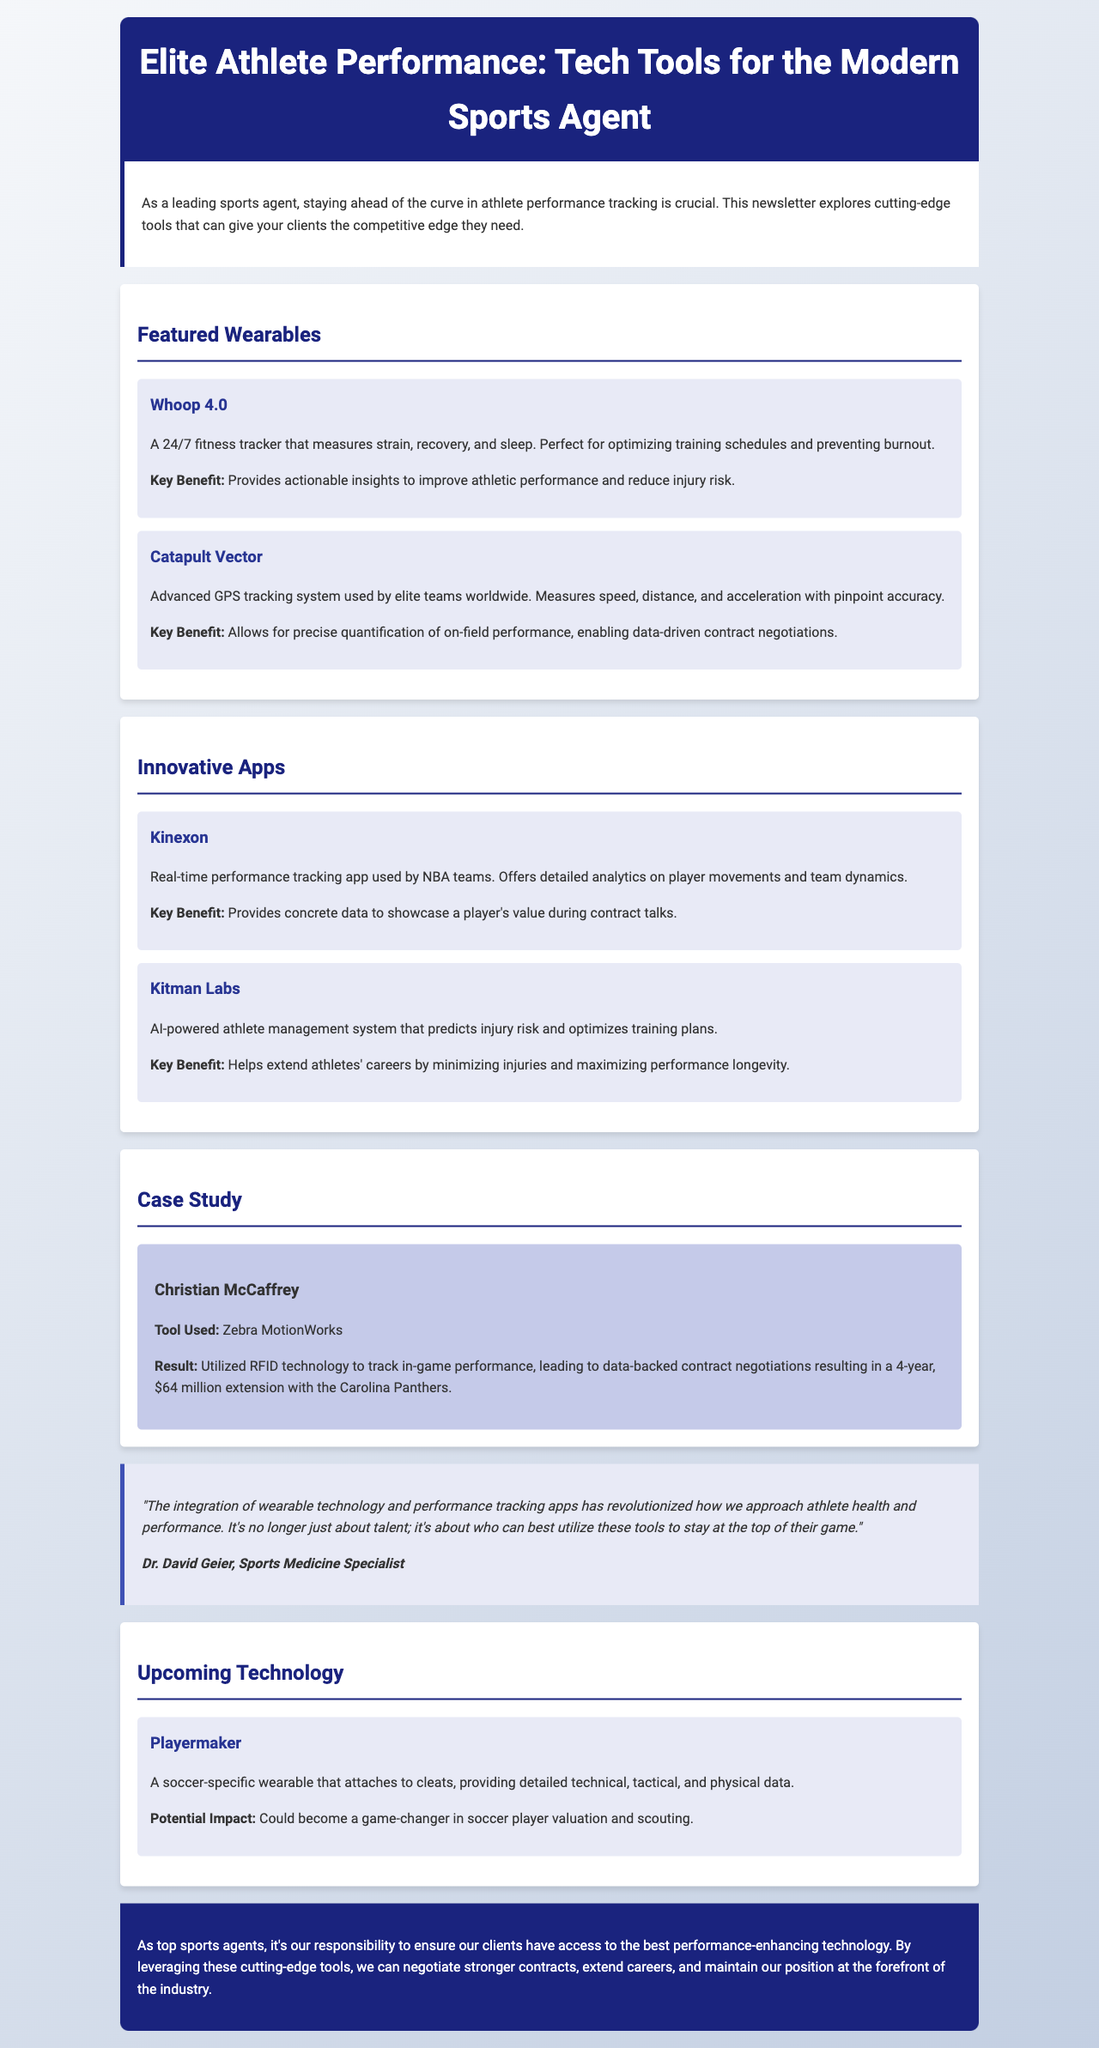what is the title of the newsletter? The title of the newsletter is the main heading presented at the top of the document.
Answer: Elite Athlete Performance: Tech Tools for the Modern Sports Agent which wearable is described as a 24/7 fitness tracker? This information can be found in the section detailing the featured wearables.
Answer: Whoop 4.0 who is the athlete mentioned in the case study? This is the name of the athlete highlighted in the specific case study section of the document.
Answer: Christian McCaffrey what is the key benefit of Kitman Labs? This benefit is provided in the description of the innovative apps and it highlights the specific advantage offered by the app.
Answer: Helps extend athletes' careers by minimizing injuries and maximizing performance longevity what technology does Playermaker pertain to? This describes the type of technology being introduced and its specific application.
Answer: A soccer-specific wearable how much was Christian McCaffrey's contract extension worth? This figure is stated in the results of the case study indicating the financial outcome of the negotiations.
Answer: $64 million which expert provided a quote in the document? This is the name of the specialist who offered insights in the form of a quote.
Answer: Dr. David Geier what is the main responsibility of top sports agents according to the conclusion? This identifies the role and duty that sports agents are encouraged to prioritize as indicated in the concluding section.
Answer: Ensure clients have access to the best performance-enhancing technology 